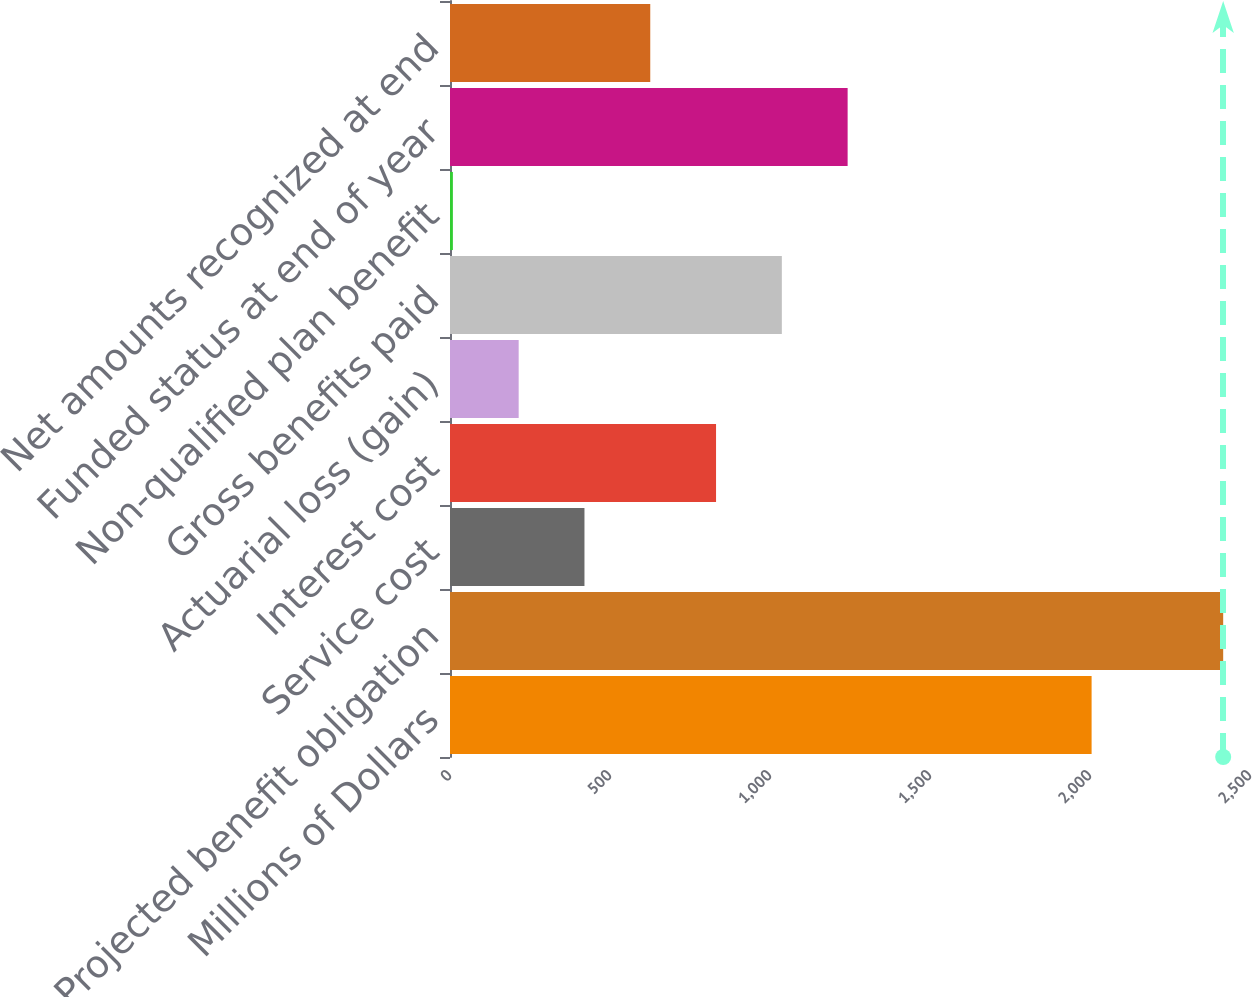Convert chart to OTSL. <chart><loc_0><loc_0><loc_500><loc_500><bar_chart><fcel>Millions of Dollars<fcel>Projected benefit obligation<fcel>Service cost<fcel>Interest cost<fcel>Actuarial loss (gain)<fcel>Gross benefits paid<fcel>Non-qualified plan benefit<fcel>Funded status at end of year<fcel>Net amounts recognized at end<nl><fcel>2005<fcel>2416.2<fcel>420.2<fcel>831.4<fcel>214.6<fcel>1037<fcel>9<fcel>1242.6<fcel>625.8<nl></chart> 